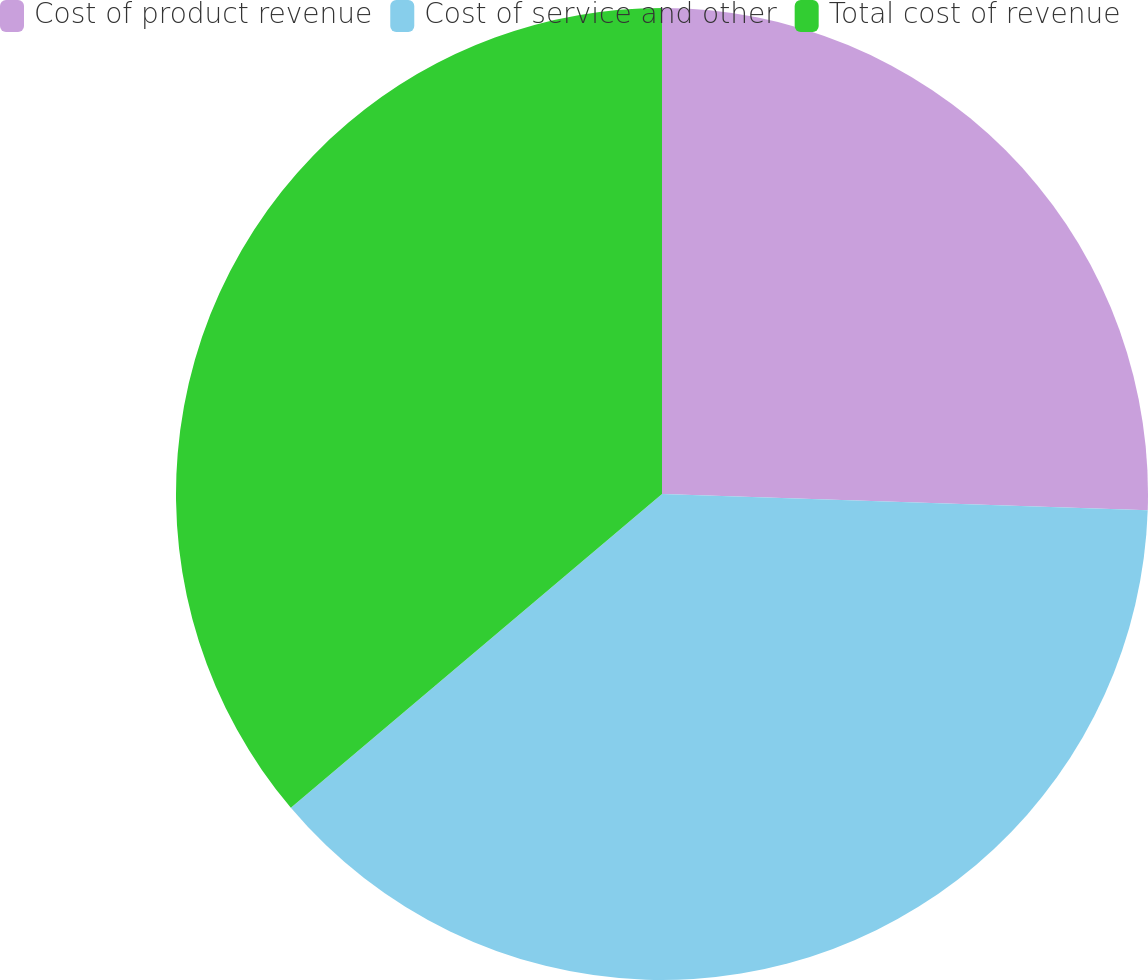<chart> <loc_0><loc_0><loc_500><loc_500><pie_chart><fcel>Cost of product revenue<fcel>Cost of service and other<fcel>Total cost of revenue<nl><fcel>25.53%<fcel>38.3%<fcel>36.17%<nl></chart> 